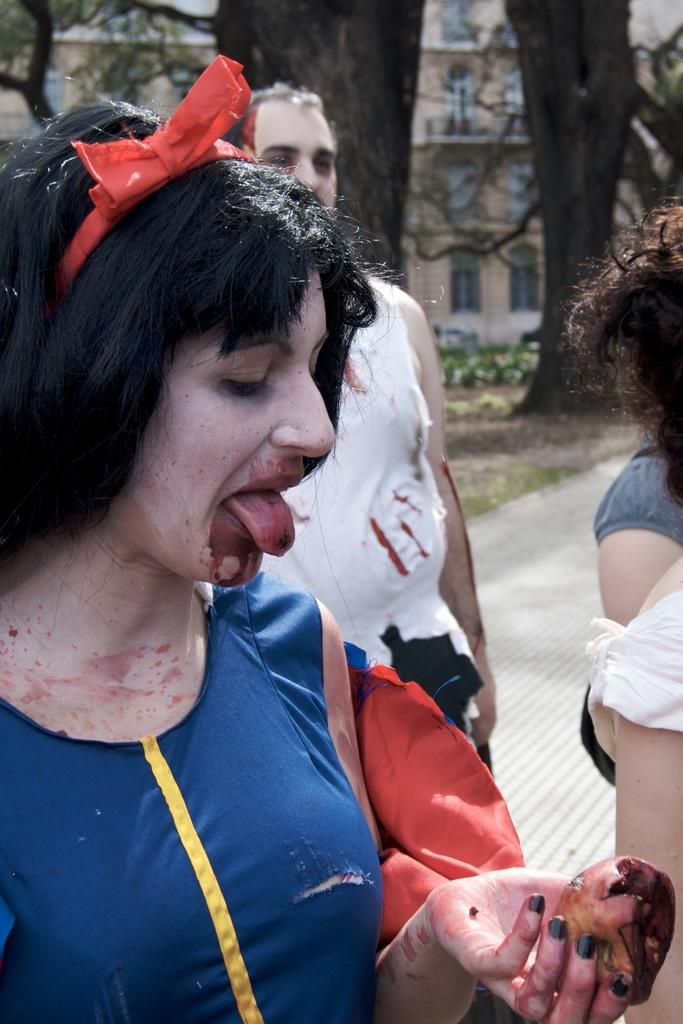What is happening in the image? There are people standing in the image. What can be seen in the background of the image? There are trees, buildings, and grass visible in the background of the image. What type of knife is being used by the people in the image? There is no knife present in the image; the people are simply standing. What kind of beast can be seen hiding behind the trees in the image? There is no beast present in the image; only trees, buildings, and grass are visible in the background. 